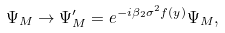<formula> <loc_0><loc_0><loc_500><loc_500>\Psi _ { M } \rightarrow \Psi _ { M } ^ { \prime } = e ^ { - i \beta _ { 2 } \sigma ^ { 2 } f ( y ) } \Psi _ { M } ,</formula> 